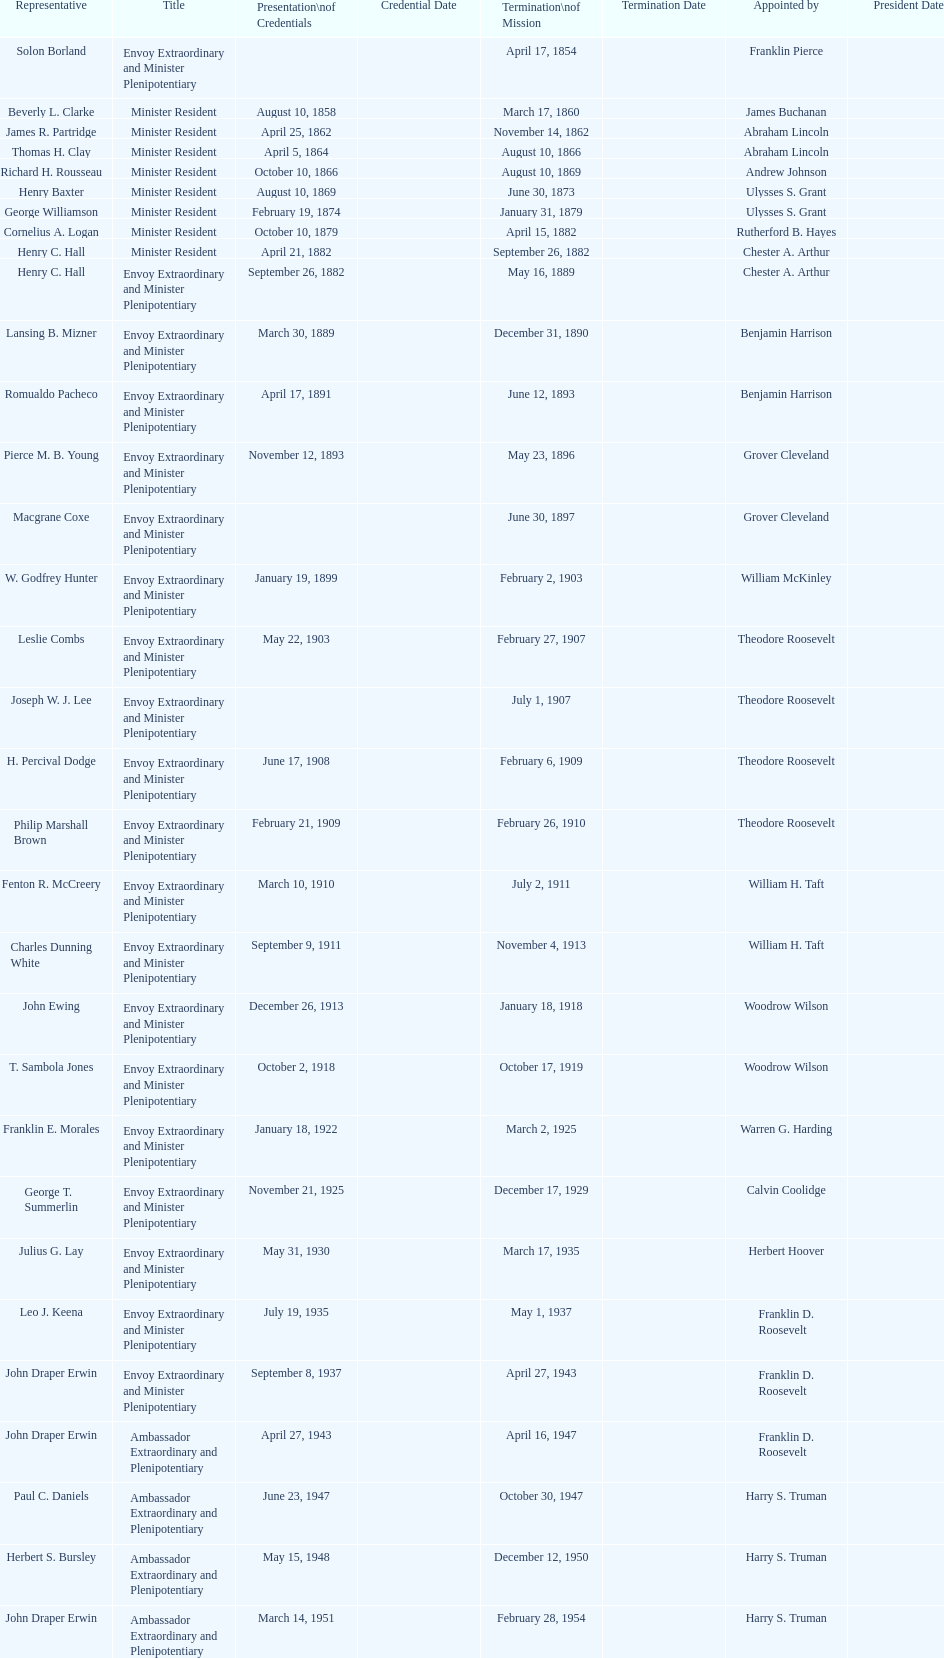What was the length, in years, of leslie combs' term? 4 years. Could you parse the entire table? {'header': ['Representative', 'Title', 'Presentation\\nof Credentials', 'Credential Date', 'Termination\\nof Mission', 'Termination Date', 'Appointed by', 'President Date'], 'rows': [['Solon Borland', 'Envoy Extraordinary and Minister Plenipotentiary', '', '', 'April 17, 1854', '', 'Franklin Pierce', ''], ['Beverly L. Clarke', 'Minister Resident', 'August 10, 1858', '', 'March 17, 1860', '', 'James Buchanan', ''], ['James R. Partridge', 'Minister Resident', 'April 25, 1862', '', 'November 14, 1862', '', 'Abraham Lincoln', ''], ['Thomas H. Clay', 'Minister Resident', 'April 5, 1864', '', 'August 10, 1866', '', 'Abraham Lincoln', ''], ['Richard H. Rousseau', 'Minister Resident', 'October 10, 1866', '', 'August 10, 1869', '', 'Andrew Johnson', ''], ['Henry Baxter', 'Minister Resident', 'August 10, 1869', '', 'June 30, 1873', '', 'Ulysses S. Grant', ''], ['George Williamson', 'Minister Resident', 'February 19, 1874', '', 'January 31, 1879', '', 'Ulysses S. Grant', ''], ['Cornelius A. Logan', 'Minister Resident', 'October 10, 1879', '', 'April 15, 1882', '', 'Rutherford B. Hayes', ''], ['Henry C. Hall', 'Minister Resident', 'April 21, 1882', '', 'September 26, 1882', '', 'Chester A. Arthur', ''], ['Henry C. Hall', 'Envoy Extraordinary and Minister Plenipotentiary', 'September 26, 1882', '', 'May 16, 1889', '', 'Chester A. Arthur', ''], ['Lansing B. Mizner', 'Envoy Extraordinary and Minister Plenipotentiary', 'March 30, 1889', '', 'December 31, 1890', '', 'Benjamin Harrison', ''], ['Romualdo Pacheco', 'Envoy Extraordinary and Minister Plenipotentiary', 'April 17, 1891', '', 'June 12, 1893', '', 'Benjamin Harrison', ''], ['Pierce M. B. Young', 'Envoy Extraordinary and Minister Plenipotentiary', 'November 12, 1893', '', 'May 23, 1896', '', 'Grover Cleveland', ''], ['Macgrane Coxe', 'Envoy Extraordinary and Minister Plenipotentiary', '', '', 'June 30, 1897', '', 'Grover Cleveland', ''], ['W. Godfrey Hunter', 'Envoy Extraordinary and Minister Plenipotentiary', 'January 19, 1899', '', 'February 2, 1903', '', 'William McKinley', ''], ['Leslie Combs', 'Envoy Extraordinary and Minister Plenipotentiary', 'May 22, 1903', '', 'February 27, 1907', '', 'Theodore Roosevelt', ''], ['Joseph W. J. Lee', 'Envoy Extraordinary and Minister Plenipotentiary', '', '', 'July 1, 1907', '', 'Theodore Roosevelt', ''], ['H. Percival Dodge', 'Envoy Extraordinary and Minister Plenipotentiary', 'June 17, 1908', '', 'February 6, 1909', '', 'Theodore Roosevelt', ''], ['Philip Marshall Brown', 'Envoy Extraordinary and Minister Plenipotentiary', 'February 21, 1909', '', 'February 26, 1910', '', 'Theodore Roosevelt', ''], ['Fenton R. McCreery', 'Envoy Extraordinary and Minister Plenipotentiary', 'March 10, 1910', '', 'July 2, 1911', '', 'William H. Taft', ''], ['Charles Dunning White', 'Envoy Extraordinary and Minister Plenipotentiary', 'September 9, 1911', '', 'November 4, 1913', '', 'William H. Taft', ''], ['John Ewing', 'Envoy Extraordinary and Minister Plenipotentiary', 'December 26, 1913', '', 'January 18, 1918', '', 'Woodrow Wilson', ''], ['T. Sambola Jones', 'Envoy Extraordinary and Minister Plenipotentiary', 'October 2, 1918', '', 'October 17, 1919', '', 'Woodrow Wilson', ''], ['Franklin E. Morales', 'Envoy Extraordinary and Minister Plenipotentiary', 'January 18, 1922', '', 'March 2, 1925', '', 'Warren G. Harding', ''], ['George T. Summerlin', 'Envoy Extraordinary and Minister Plenipotentiary', 'November 21, 1925', '', 'December 17, 1929', '', 'Calvin Coolidge', ''], ['Julius G. Lay', 'Envoy Extraordinary and Minister Plenipotentiary', 'May 31, 1930', '', 'March 17, 1935', '', 'Herbert Hoover', ''], ['Leo J. Keena', 'Envoy Extraordinary and Minister Plenipotentiary', 'July 19, 1935', '', 'May 1, 1937', '', 'Franklin D. Roosevelt', ''], ['John Draper Erwin', 'Envoy Extraordinary and Minister Plenipotentiary', 'September 8, 1937', '', 'April 27, 1943', '', 'Franklin D. Roosevelt', ''], ['John Draper Erwin', 'Ambassador Extraordinary and Plenipotentiary', 'April 27, 1943', '', 'April 16, 1947', '', 'Franklin D. Roosevelt', ''], ['Paul C. Daniels', 'Ambassador Extraordinary and Plenipotentiary', 'June 23, 1947', '', 'October 30, 1947', '', 'Harry S. Truman', ''], ['Herbert S. Bursley', 'Ambassador Extraordinary and Plenipotentiary', 'May 15, 1948', '', 'December 12, 1950', '', 'Harry S. Truman', ''], ['John Draper Erwin', 'Ambassador Extraordinary and Plenipotentiary', 'March 14, 1951', '', 'February 28, 1954', '', 'Harry S. Truman', ''], ['Whiting Willauer', 'Ambassador Extraordinary and Plenipotentiary', 'March 5, 1954', '', 'March 24, 1958', '', 'Dwight D. Eisenhower', ''], ['Robert Newbegin', 'Ambassador Extraordinary and Plenipotentiary', 'April 30, 1958', '', 'August 3, 1960', '', 'Dwight D. Eisenhower', ''], ['Charles R. Burrows', 'Ambassador Extraordinary and Plenipotentiary', 'November 3, 1960', '', 'June 28, 1965', '', 'Dwight D. Eisenhower', ''], ['Joseph J. Jova', 'Ambassador Extraordinary and Plenipotentiary', 'July 12, 1965', '', 'June 21, 1969', '', 'Lyndon B. Johnson', ''], ['Hewson A. Ryan', 'Ambassador Extraordinary and Plenipotentiary', 'November 5, 1969', '', 'May 30, 1973', '', 'Richard Nixon', ''], ['Phillip V. Sanchez', 'Ambassador Extraordinary and Plenipotentiary', 'June 15, 1973', '', 'July 17, 1976', '', 'Richard Nixon', ''], ['Ralph E. Becker', 'Ambassador Extraordinary and Plenipotentiary', 'October 27, 1976', '', 'August 1, 1977', '', 'Gerald Ford', ''], ['Mari-Luci Jaramillo', 'Ambassador Extraordinary and Plenipotentiary', 'October 27, 1977', '', 'September 19, 1980', '', 'Jimmy Carter', ''], ['Jack R. Binns', 'Ambassador Extraordinary and Plenipotentiary', 'October 10, 1980', '', 'October 31, 1981', '', 'Jimmy Carter', ''], ['John D. Negroponte', 'Ambassador Extraordinary and Plenipotentiary', 'November 11, 1981', '', 'May 30, 1985', '', 'Ronald Reagan', ''], ['John Arthur Ferch', 'Ambassador Extraordinary and Plenipotentiary', 'August 22, 1985', '', 'July 9, 1986', '', 'Ronald Reagan', ''], ['Everett Ellis Briggs', 'Ambassador Extraordinary and Plenipotentiary', 'November 4, 1986', '', 'June 15, 1989', '', 'Ronald Reagan', ''], ['Cresencio S. Arcos, Jr.', 'Ambassador Extraordinary and Plenipotentiary', 'January 29, 1990', '', 'July 1, 1993', '', 'George H. W. Bush', ''], ['William Thornton Pryce', 'Ambassador Extraordinary and Plenipotentiary', 'July 21, 1993', '', 'August 15, 1996', '', 'Bill Clinton', ''], ['James F. Creagan', 'Ambassador Extraordinary and Plenipotentiary', 'August 29, 1996', '', 'July 20, 1999', '', 'Bill Clinton', ''], ['Frank Almaguer', 'Ambassador Extraordinary and Plenipotentiary', 'August 25, 1999', '', 'September 5, 2002', '', 'Bill Clinton', ''], ['Larry Leon Palmer', 'Ambassador Extraordinary and Plenipotentiary', 'October 8, 2002', '', 'May 7, 2005', '', 'George W. Bush', ''], ['Charles A. Ford', 'Ambassador Extraordinary and Plenipotentiary', 'November 8, 2005', '', 'ca. April 2008', '', 'George W. Bush', ''], ['Hugo Llorens', 'Ambassador Extraordinary and Plenipotentiary', 'September 19, 2008', '', 'ca. July 2011', '', 'George W. Bush', ''], ['Lisa Kubiske', 'Ambassador Extraordinary and Plenipotentiary', 'July 26, 2011', '', 'Incumbent', '', 'Barack Obama', '']]} 